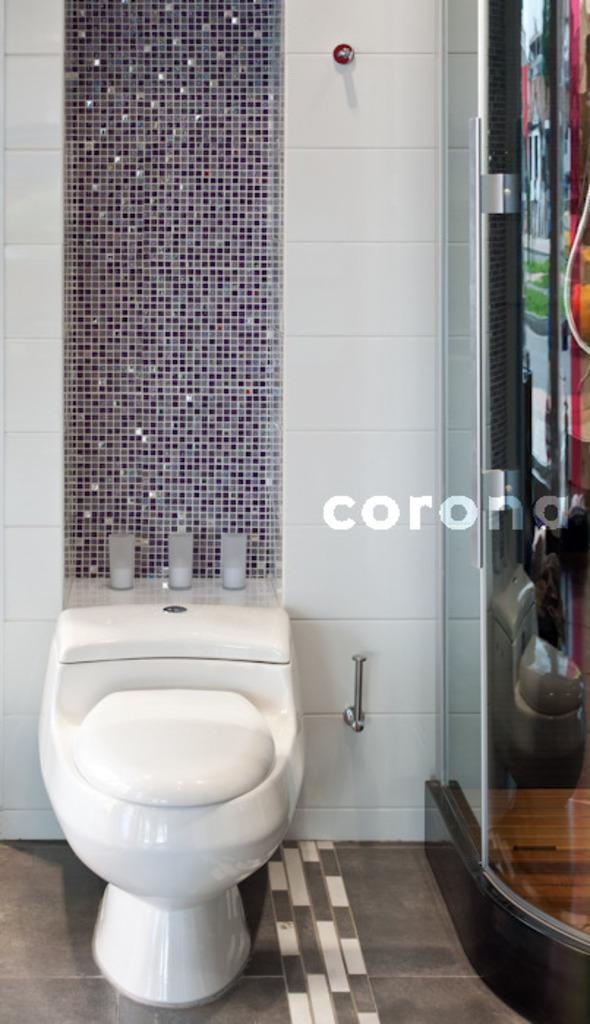What can be found in the image that is commonly used for personal hygiene? There is a toilet seat in the image. What material is used for the objects in the image? The metal rods in the image are made of metal. What is the background of the image? There is a wall in the image. What is located beside the toilet seat? There is a door beside the toilet seat in the image. What type of insect can be seen crawling on the toilet seat in the image? There are no insects present in the image; it only features a toilet seat, metal rods, a wall, and a door. 